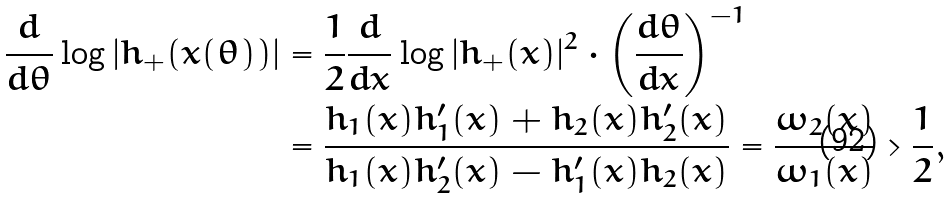Convert formula to latex. <formula><loc_0><loc_0><loc_500><loc_500>\frac { d } { d \theta } \log | h _ { + } ( x ( \theta ) ) | & = \frac { 1 } { 2 } \frac { d } { d x } \log | h _ { + } ( x ) | ^ { 2 } \cdot \left ( \frac { d \theta } { d x } \right ) ^ { - 1 } \\ & = \frac { h _ { 1 } ( x ) h _ { 1 } ^ { \prime } ( x ) + h _ { 2 } ( x ) h _ { 2 } ^ { \prime } ( x ) } { h _ { 1 } ( x ) h _ { 2 } ^ { \prime } ( x ) - h _ { 1 } ^ { \prime } ( x ) h _ { 2 } ( x ) } = \frac { \omega _ { 2 } ( x ) } { \omega _ { 1 } ( x ) } > \frac { 1 } { 2 } ,</formula> 